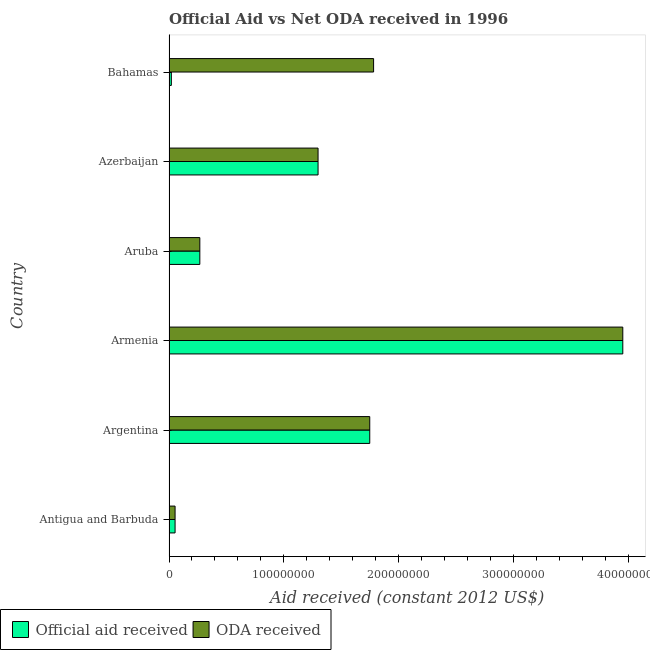How many different coloured bars are there?
Make the answer very short. 2. How many groups of bars are there?
Keep it short and to the point. 6. Are the number of bars per tick equal to the number of legend labels?
Make the answer very short. Yes. How many bars are there on the 6th tick from the top?
Keep it short and to the point. 2. How many bars are there on the 3rd tick from the bottom?
Offer a very short reply. 2. What is the label of the 2nd group of bars from the top?
Offer a terse response. Azerbaijan. In how many cases, is the number of bars for a given country not equal to the number of legend labels?
Offer a terse response. 0. What is the official aid received in Antigua and Barbuda?
Your answer should be very brief. 5.29e+06. Across all countries, what is the maximum official aid received?
Provide a succinct answer. 3.95e+08. Across all countries, what is the minimum official aid received?
Your response must be concise. 2.04e+06. In which country was the oda received maximum?
Your answer should be very brief. Armenia. In which country was the oda received minimum?
Offer a very short reply. Antigua and Barbuda. What is the total oda received in the graph?
Make the answer very short. 9.10e+08. What is the difference between the oda received in Antigua and Barbuda and that in Argentina?
Make the answer very short. -1.70e+08. What is the difference between the official aid received in Bahamas and the oda received in Aruba?
Your answer should be compact. -2.48e+07. What is the average oda received per country?
Keep it short and to the point. 1.52e+08. What is the ratio of the oda received in Argentina to that in Bahamas?
Offer a terse response. 0.98. Is the difference between the official aid received in Antigua and Barbuda and Bahamas greater than the difference between the oda received in Antigua and Barbuda and Bahamas?
Your answer should be compact. Yes. What is the difference between the highest and the second highest official aid received?
Your answer should be very brief. 2.20e+08. What is the difference between the highest and the lowest oda received?
Your answer should be very brief. 3.90e+08. In how many countries, is the oda received greater than the average oda received taken over all countries?
Keep it short and to the point. 3. Is the sum of the official aid received in Antigua and Barbuda and Aruba greater than the maximum oda received across all countries?
Offer a terse response. No. What does the 1st bar from the top in Azerbaijan represents?
Your answer should be compact. ODA received. What does the 1st bar from the bottom in Bahamas represents?
Make the answer very short. Official aid received. How many bars are there?
Give a very brief answer. 12. How many countries are there in the graph?
Ensure brevity in your answer.  6. What is the difference between two consecutive major ticks on the X-axis?
Offer a very short reply. 1.00e+08. What is the title of the graph?
Your response must be concise. Official Aid vs Net ODA received in 1996 . Does "Exports" appear as one of the legend labels in the graph?
Make the answer very short. No. What is the label or title of the X-axis?
Offer a terse response. Aid received (constant 2012 US$). What is the Aid received (constant 2012 US$) in Official aid received in Antigua and Barbuda?
Provide a succinct answer. 5.29e+06. What is the Aid received (constant 2012 US$) of ODA received in Antigua and Barbuda?
Your response must be concise. 5.29e+06. What is the Aid received (constant 2012 US$) of Official aid received in Argentina?
Keep it short and to the point. 1.75e+08. What is the Aid received (constant 2012 US$) of ODA received in Argentina?
Offer a very short reply. 1.75e+08. What is the Aid received (constant 2012 US$) of Official aid received in Armenia?
Your answer should be compact. 3.95e+08. What is the Aid received (constant 2012 US$) in ODA received in Armenia?
Keep it short and to the point. 3.95e+08. What is the Aid received (constant 2012 US$) in Official aid received in Aruba?
Your answer should be very brief. 2.68e+07. What is the Aid received (constant 2012 US$) of ODA received in Aruba?
Offer a very short reply. 2.68e+07. What is the Aid received (constant 2012 US$) in Official aid received in Azerbaijan?
Provide a succinct answer. 1.30e+08. What is the Aid received (constant 2012 US$) in ODA received in Azerbaijan?
Give a very brief answer. 1.30e+08. What is the Aid received (constant 2012 US$) of Official aid received in Bahamas?
Provide a short and direct response. 2.04e+06. What is the Aid received (constant 2012 US$) of ODA received in Bahamas?
Ensure brevity in your answer.  1.78e+08. Across all countries, what is the maximum Aid received (constant 2012 US$) in Official aid received?
Your answer should be very brief. 3.95e+08. Across all countries, what is the maximum Aid received (constant 2012 US$) in ODA received?
Provide a succinct answer. 3.95e+08. Across all countries, what is the minimum Aid received (constant 2012 US$) of Official aid received?
Provide a short and direct response. 2.04e+06. Across all countries, what is the minimum Aid received (constant 2012 US$) of ODA received?
Make the answer very short. 5.29e+06. What is the total Aid received (constant 2012 US$) of Official aid received in the graph?
Keep it short and to the point. 7.34e+08. What is the total Aid received (constant 2012 US$) in ODA received in the graph?
Your answer should be compact. 9.10e+08. What is the difference between the Aid received (constant 2012 US$) in Official aid received in Antigua and Barbuda and that in Argentina?
Provide a short and direct response. -1.70e+08. What is the difference between the Aid received (constant 2012 US$) in ODA received in Antigua and Barbuda and that in Argentina?
Your answer should be compact. -1.70e+08. What is the difference between the Aid received (constant 2012 US$) in Official aid received in Antigua and Barbuda and that in Armenia?
Provide a short and direct response. -3.90e+08. What is the difference between the Aid received (constant 2012 US$) of ODA received in Antigua and Barbuda and that in Armenia?
Provide a short and direct response. -3.90e+08. What is the difference between the Aid received (constant 2012 US$) of Official aid received in Antigua and Barbuda and that in Aruba?
Offer a very short reply. -2.16e+07. What is the difference between the Aid received (constant 2012 US$) of ODA received in Antigua and Barbuda and that in Aruba?
Your answer should be compact. -2.16e+07. What is the difference between the Aid received (constant 2012 US$) in Official aid received in Antigua and Barbuda and that in Azerbaijan?
Keep it short and to the point. -1.25e+08. What is the difference between the Aid received (constant 2012 US$) of ODA received in Antigua and Barbuda and that in Azerbaijan?
Provide a succinct answer. -1.25e+08. What is the difference between the Aid received (constant 2012 US$) of Official aid received in Antigua and Barbuda and that in Bahamas?
Keep it short and to the point. 3.25e+06. What is the difference between the Aid received (constant 2012 US$) in ODA received in Antigua and Barbuda and that in Bahamas?
Your answer should be compact. -1.73e+08. What is the difference between the Aid received (constant 2012 US$) of Official aid received in Argentina and that in Armenia?
Offer a terse response. -2.20e+08. What is the difference between the Aid received (constant 2012 US$) in ODA received in Argentina and that in Armenia?
Your answer should be very brief. -2.20e+08. What is the difference between the Aid received (constant 2012 US$) of Official aid received in Argentina and that in Aruba?
Make the answer very short. 1.48e+08. What is the difference between the Aid received (constant 2012 US$) in ODA received in Argentina and that in Aruba?
Provide a short and direct response. 1.48e+08. What is the difference between the Aid received (constant 2012 US$) in Official aid received in Argentina and that in Azerbaijan?
Ensure brevity in your answer.  4.50e+07. What is the difference between the Aid received (constant 2012 US$) in ODA received in Argentina and that in Azerbaijan?
Ensure brevity in your answer.  4.50e+07. What is the difference between the Aid received (constant 2012 US$) in Official aid received in Argentina and that in Bahamas?
Provide a short and direct response. 1.73e+08. What is the difference between the Aid received (constant 2012 US$) in ODA received in Argentina and that in Bahamas?
Offer a terse response. -3.35e+06. What is the difference between the Aid received (constant 2012 US$) of Official aid received in Armenia and that in Aruba?
Your answer should be compact. 3.68e+08. What is the difference between the Aid received (constant 2012 US$) of ODA received in Armenia and that in Aruba?
Give a very brief answer. 3.68e+08. What is the difference between the Aid received (constant 2012 US$) in Official aid received in Armenia and that in Azerbaijan?
Offer a terse response. 2.65e+08. What is the difference between the Aid received (constant 2012 US$) in ODA received in Armenia and that in Azerbaijan?
Your answer should be very brief. 2.65e+08. What is the difference between the Aid received (constant 2012 US$) of Official aid received in Armenia and that in Bahamas?
Offer a terse response. 3.93e+08. What is the difference between the Aid received (constant 2012 US$) of ODA received in Armenia and that in Bahamas?
Keep it short and to the point. 2.17e+08. What is the difference between the Aid received (constant 2012 US$) of Official aid received in Aruba and that in Azerbaijan?
Provide a succinct answer. -1.03e+08. What is the difference between the Aid received (constant 2012 US$) of ODA received in Aruba and that in Azerbaijan?
Your answer should be compact. -1.03e+08. What is the difference between the Aid received (constant 2012 US$) of Official aid received in Aruba and that in Bahamas?
Your answer should be compact. 2.48e+07. What is the difference between the Aid received (constant 2012 US$) of ODA received in Aruba and that in Bahamas?
Make the answer very short. -1.51e+08. What is the difference between the Aid received (constant 2012 US$) in Official aid received in Azerbaijan and that in Bahamas?
Provide a short and direct response. 1.28e+08. What is the difference between the Aid received (constant 2012 US$) of ODA received in Azerbaijan and that in Bahamas?
Offer a very short reply. -4.84e+07. What is the difference between the Aid received (constant 2012 US$) in Official aid received in Antigua and Barbuda and the Aid received (constant 2012 US$) in ODA received in Argentina?
Ensure brevity in your answer.  -1.70e+08. What is the difference between the Aid received (constant 2012 US$) of Official aid received in Antigua and Barbuda and the Aid received (constant 2012 US$) of ODA received in Armenia?
Offer a terse response. -3.90e+08. What is the difference between the Aid received (constant 2012 US$) in Official aid received in Antigua and Barbuda and the Aid received (constant 2012 US$) in ODA received in Aruba?
Offer a terse response. -2.16e+07. What is the difference between the Aid received (constant 2012 US$) in Official aid received in Antigua and Barbuda and the Aid received (constant 2012 US$) in ODA received in Azerbaijan?
Give a very brief answer. -1.25e+08. What is the difference between the Aid received (constant 2012 US$) of Official aid received in Antigua and Barbuda and the Aid received (constant 2012 US$) of ODA received in Bahamas?
Offer a terse response. -1.73e+08. What is the difference between the Aid received (constant 2012 US$) in Official aid received in Argentina and the Aid received (constant 2012 US$) in ODA received in Armenia?
Your answer should be very brief. -2.20e+08. What is the difference between the Aid received (constant 2012 US$) of Official aid received in Argentina and the Aid received (constant 2012 US$) of ODA received in Aruba?
Your response must be concise. 1.48e+08. What is the difference between the Aid received (constant 2012 US$) of Official aid received in Argentina and the Aid received (constant 2012 US$) of ODA received in Azerbaijan?
Offer a very short reply. 4.50e+07. What is the difference between the Aid received (constant 2012 US$) of Official aid received in Argentina and the Aid received (constant 2012 US$) of ODA received in Bahamas?
Ensure brevity in your answer.  -3.35e+06. What is the difference between the Aid received (constant 2012 US$) of Official aid received in Armenia and the Aid received (constant 2012 US$) of ODA received in Aruba?
Offer a very short reply. 3.68e+08. What is the difference between the Aid received (constant 2012 US$) of Official aid received in Armenia and the Aid received (constant 2012 US$) of ODA received in Azerbaijan?
Your response must be concise. 2.65e+08. What is the difference between the Aid received (constant 2012 US$) of Official aid received in Armenia and the Aid received (constant 2012 US$) of ODA received in Bahamas?
Give a very brief answer. 2.17e+08. What is the difference between the Aid received (constant 2012 US$) of Official aid received in Aruba and the Aid received (constant 2012 US$) of ODA received in Azerbaijan?
Provide a succinct answer. -1.03e+08. What is the difference between the Aid received (constant 2012 US$) in Official aid received in Aruba and the Aid received (constant 2012 US$) in ODA received in Bahamas?
Your response must be concise. -1.51e+08. What is the difference between the Aid received (constant 2012 US$) in Official aid received in Azerbaijan and the Aid received (constant 2012 US$) in ODA received in Bahamas?
Offer a terse response. -4.84e+07. What is the average Aid received (constant 2012 US$) in Official aid received per country?
Your response must be concise. 1.22e+08. What is the average Aid received (constant 2012 US$) in ODA received per country?
Your response must be concise. 1.52e+08. What is the difference between the Aid received (constant 2012 US$) in Official aid received and Aid received (constant 2012 US$) in ODA received in Antigua and Barbuda?
Offer a very short reply. 0. What is the difference between the Aid received (constant 2012 US$) in Official aid received and Aid received (constant 2012 US$) in ODA received in Aruba?
Keep it short and to the point. 0. What is the difference between the Aid received (constant 2012 US$) in Official aid received and Aid received (constant 2012 US$) in ODA received in Bahamas?
Give a very brief answer. -1.76e+08. What is the ratio of the Aid received (constant 2012 US$) of Official aid received in Antigua and Barbuda to that in Argentina?
Your response must be concise. 0.03. What is the ratio of the Aid received (constant 2012 US$) in ODA received in Antigua and Barbuda to that in Argentina?
Your answer should be compact. 0.03. What is the ratio of the Aid received (constant 2012 US$) of Official aid received in Antigua and Barbuda to that in Armenia?
Keep it short and to the point. 0.01. What is the ratio of the Aid received (constant 2012 US$) of ODA received in Antigua and Barbuda to that in Armenia?
Your answer should be compact. 0.01. What is the ratio of the Aid received (constant 2012 US$) of Official aid received in Antigua and Barbuda to that in Aruba?
Make the answer very short. 0.2. What is the ratio of the Aid received (constant 2012 US$) in ODA received in Antigua and Barbuda to that in Aruba?
Provide a short and direct response. 0.2. What is the ratio of the Aid received (constant 2012 US$) of Official aid received in Antigua and Barbuda to that in Azerbaijan?
Offer a terse response. 0.04. What is the ratio of the Aid received (constant 2012 US$) of ODA received in Antigua and Barbuda to that in Azerbaijan?
Provide a succinct answer. 0.04. What is the ratio of the Aid received (constant 2012 US$) of Official aid received in Antigua and Barbuda to that in Bahamas?
Make the answer very short. 2.59. What is the ratio of the Aid received (constant 2012 US$) of ODA received in Antigua and Barbuda to that in Bahamas?
Provide a succinct answer. 0.03. What is the ratio of the Aid received (constant 2012 US$) of Official aid received in Argentina to that in Armenia?
Your answer should be very brief. 0.44. What is the ratio of the Aid received (constant 2012 US$) of ODA received in Argentina to that in Armenia?
Your answer should be very brief. 0.44. What is the ratio of the Aid received (constant 2012 US$) of Official aid received in Argentina to that in Aruba?
Offer a terse response. 6.51. What is the ratio of the Aid received (constant 2012 US$) of ODA received in Argentina to that in Aruba?
Keep it short and to the point. 6.51. What is the ratio of the Aid received (constant 2012 US$) of Official aid received in Argentina to that in Azerbaijan?
Ensure brevity in your answer.  1.35. What is the ratio of the Aid received (constant 2012 US$) in ODA received in Argentina to that in Azerbaijan?
Keep it short and to the point. 1.35. What is the ratio of the Aid received (constant 2012 US$) of Official aid received in Argentina to that in Bahamas?
Provide a short and direct response. 85.72. What is the ratio of the Aid received (constant 2012 US$) of ODA received in Argentina to that in Bahamas?
Make the answer very short. 0.98. What is the ratio of the Aid received (constant 2012 US$) of Official aid received in Armenia to that in Aruba?
Make the answer very short. 14.72. What is the ratio of the Aid received (constant 2012 US$) in ODA received in Armenia to that in Aruba?
Offer a terse response. 14.72. What is the ratio of the Aid received (constant 2012 US$) of Official aid received in Armenia to that in Azerbaijan?
Ensure brevity in your answer.  3.04. What is the ratio of the Aid received (constant 2012 US$) of ODA received in Armenia to that in Azerbaijan?
Offer a terse response. 3.04. What is the ratio of the Aid received (constant 2012 US$) of Official aid received in Armenia to that in Bahamas?
Offer a terse response. 193.77. What is the ratio of the Aid received (constant 2012 US$) of ODA received in Armenia to that in Bahamas?
Give a very brief answer. 2.22. What is the ratio of the Aid received (constant 2012 US$) in Official aid received in Aruba to that in Azerbaijan?
Offer a terse response. 0.21. What is the ratio of the Aid received (constant 2012 US$) of ODA received in Aruba to that in Azerbaijan?
Provide a short and direct response. 0.21. What is the ratio of the Aid received (constant 2012 US$) in Official aid received in Aruba to that in Bahamas?
Make the answer very short. 13.16. What is the ratio of the Aid received (constant 2012 US$) of ODA received in Aruba to that in Bahamas?
Keep it short and to the point. 0.15. What is the ratio of the Aid received (constant 2012 US$) in Official aid received in Azerbaijan to that in Bahamas?
Your response must be concise. 63.65. What is the ratio of the Aid received (constant 2012 US$) of ODA received in Azerbaijan to that in Bahamas?
Provide a succinct answer. 0.73. What is the difference between the highest and the second highest Aid received (constant 2012 US$) in Official aid received?
Make the answer very short. 2.20e+08. What is the difference between the highest and the second highest Aid received (constant 2012 US$) of ODA received?
Offer a very short reply. 2.17e+08. What is the difference between the highest and the lowest Aid received (constant 2012 US$) in Official aid received?
Make the answer very short. 3.93e+08. What is the difference between the highest and the lowest Aid received (constant 2012 US$) in ODA received?
Give a very brief answer. 3.90e+08. 